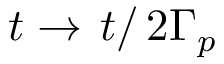<formula> <loc_0><loc_0><loc_500><loc_500>t \rightarrow t \right / 2 \Gamma _ { p }</formula> 